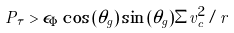Convert formula to latex. <formula><loc_0><loc_0><loc_500><loc_500>P _ { \tau } > \epsilon _ { \Phi } \cos { ( \theta _ { g } ) } \sin { ( \theta _ { g } ) } \Sigma v _ { c } ^ { 2 } / r</formula> 